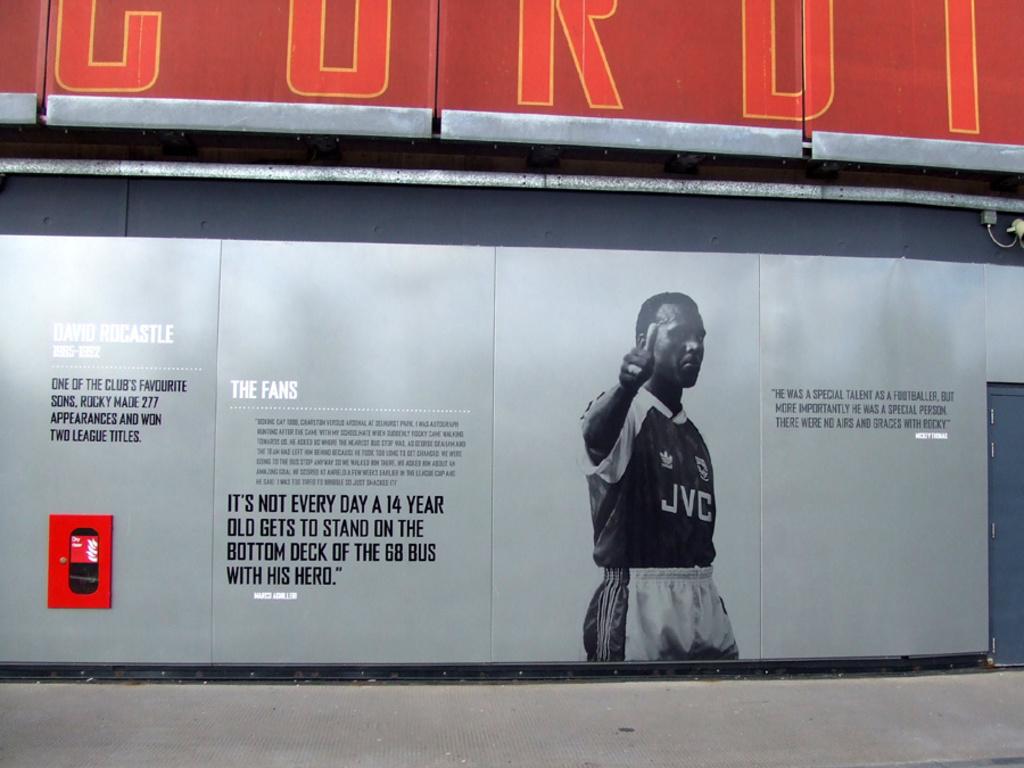What brand is on the jersey?
Keep it short and to the point. Jvc. 